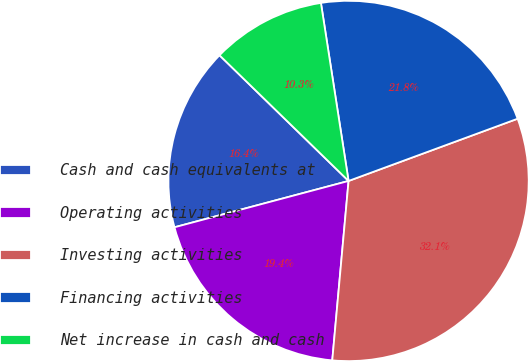Convert chart to OTSL. <chart><loc_0><loc_0><loc_500><loc_500><pie_chart><fcel>Cash and cash equivalents at<fcel>Operating activities<fcel>Investing activities<fcel>Financing activities<fcel>Net increase in cash and cash<nl><fcel>16.43%<fcel>19.42%<fcel>32.06%<fcel>21.84%<fcel>10.26%<nl></chart> 